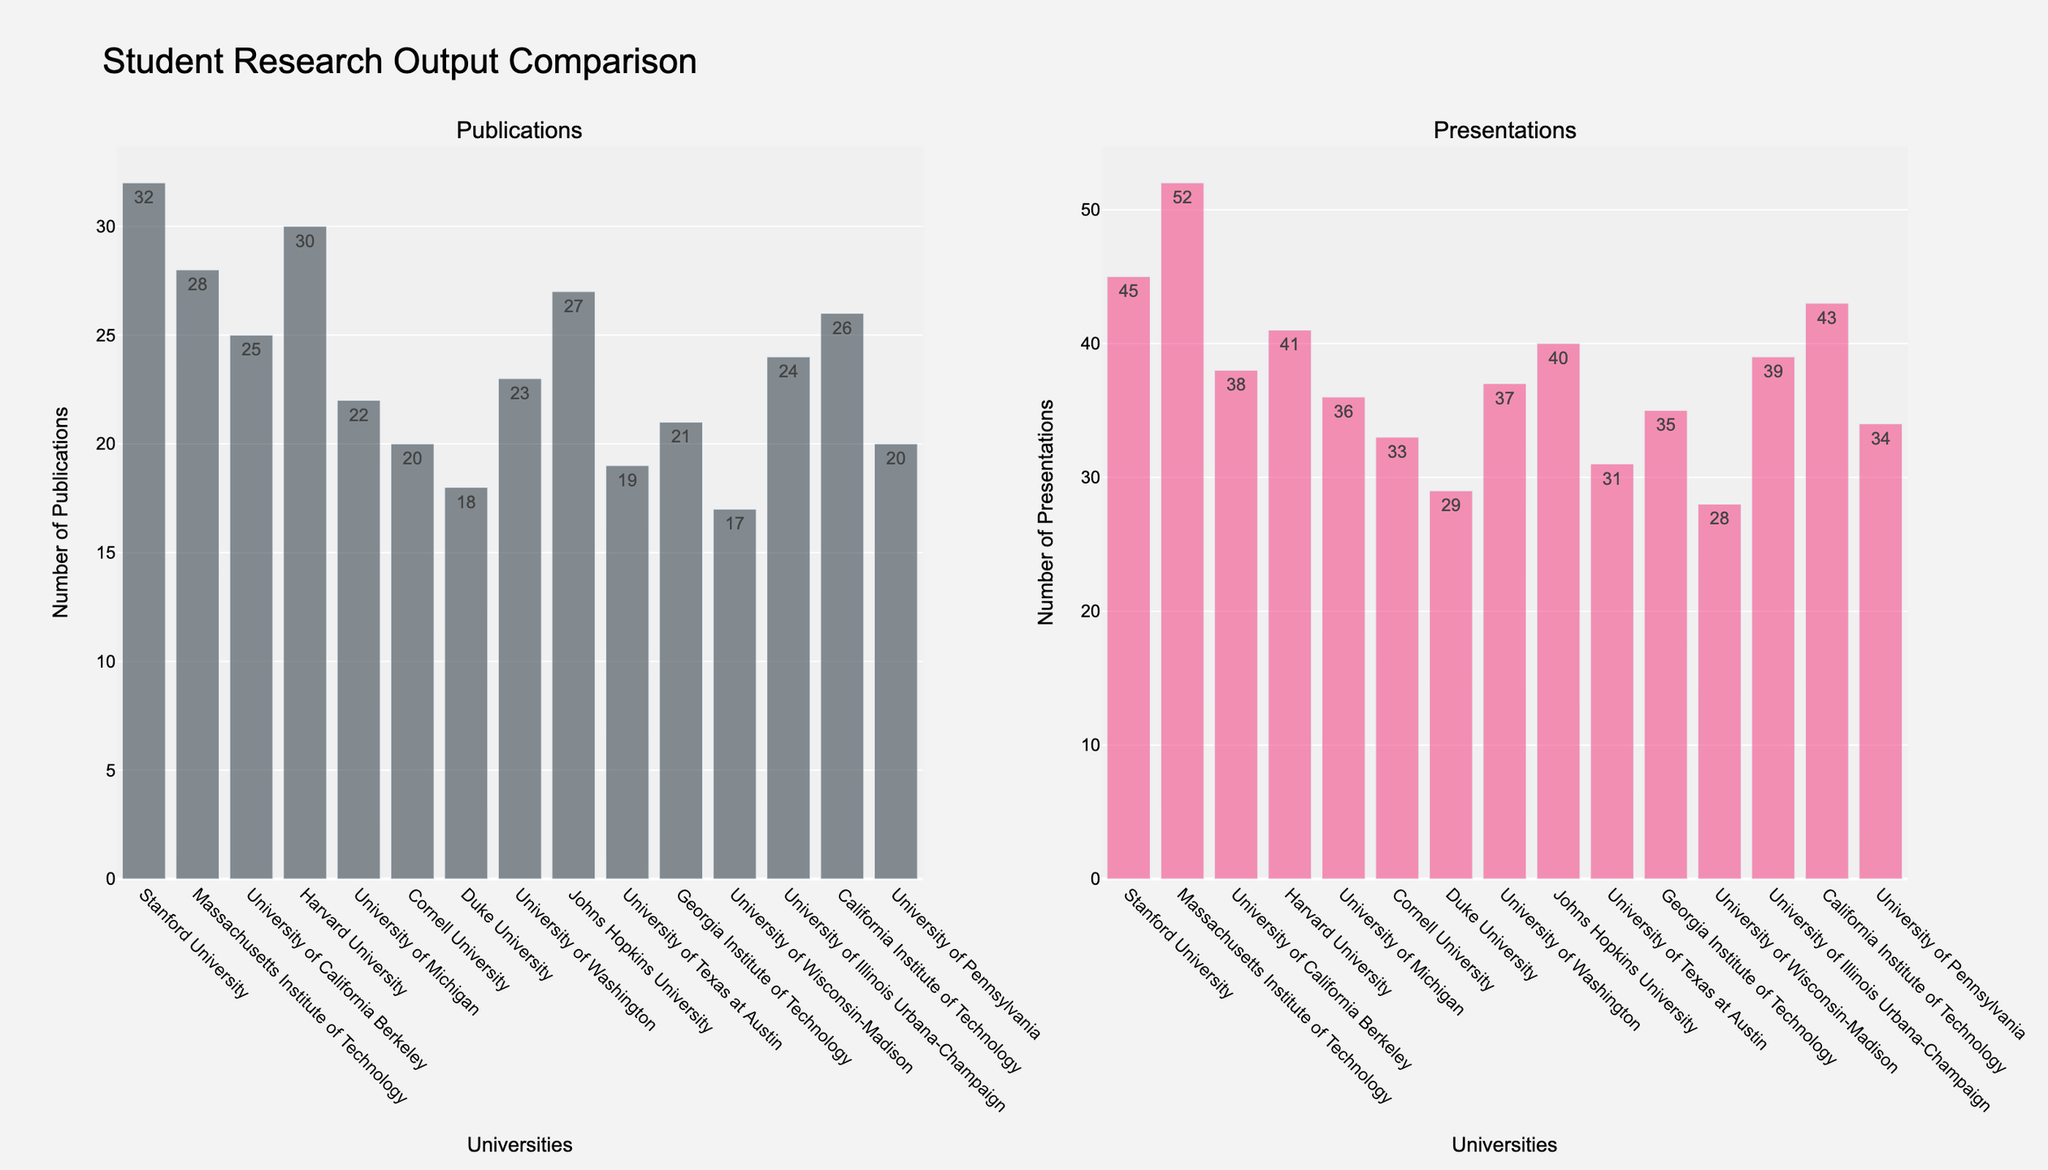What's the university with the highest number of publications? Refer to the height of the bars in the "Publications" subplot. Stanford University has the tallest bar, indicating the highest number of publications.
Answer: Stanford University Which university has more presentations, Harvard or MIT? Look at the "Presentations" subplot and compare the heights of the bars for Harvard University and Massachusetts Institute of Technology. MIT has more presentations.
Answer: MIT Which university has the lowest number of presentations? Identify the shortest bar in the "Presentations" subplot. University of Wisconsin-Madison has the shortest bar.
Answer: University of Wisconsin-Madison What is the total number of publications by Harvard and Stanford universities? Sum the values of the "Publications" for Harvard University (30) and Stanford University (32). 30 + 32 = 62.
Answer: 62 How does the number of presentations at the University of Michigan compare to the number of publications at Caltech? Refer to the "Presentations" bar height for the University of Michigan (36) and the "Publications" bar height for California Institute of Technology (26). Michigan has more presentations.
Answer: University of Michigan has more Which university has closer numbers between its publications and presentations, Johns Hopkins or University of Texas at Austin? Calculate the absolute difference between publications and presentations for both universities: Johns Hopkins (27 - 40 = 13) and University of Texas at Austin (19 - 31 = 12). The University of Texas at Austin has closer numbers.
Answer: University of Texas at Austin How much higher is the number of presentations than publications at MIT? Subtract the number of publications at MIT (28) from the number of presentations (52). 52 - 28 = 24.
Answer: 24 What's the average number of publications across all universities? Sum the number of publications (32+28+25+30+22+20+18+23+27+19+21+17+24+26+20) which equals 352. There are 15 universities, so 352 / 15 = 23.47.
Answer: 23.47 Which university has a higher combined total of publications and presentations, University of California Berkeley or University of Washington? Sum the publications and presentations for both universities: UC Berkeley (25 + 38 = 63) and University of Washington (23 + 37 = 60). UC Berkeley has a higher combined total.
Answer: UC Berkeley What is the median number of presentations across all universities? List the number of presentations in ascending order: 28, 29, 31, 33, 34, 35, 36, 37, 38, 39, 40, 41, 43, 45, 52. The median is the middle value, which is 37.
Answer: 37 